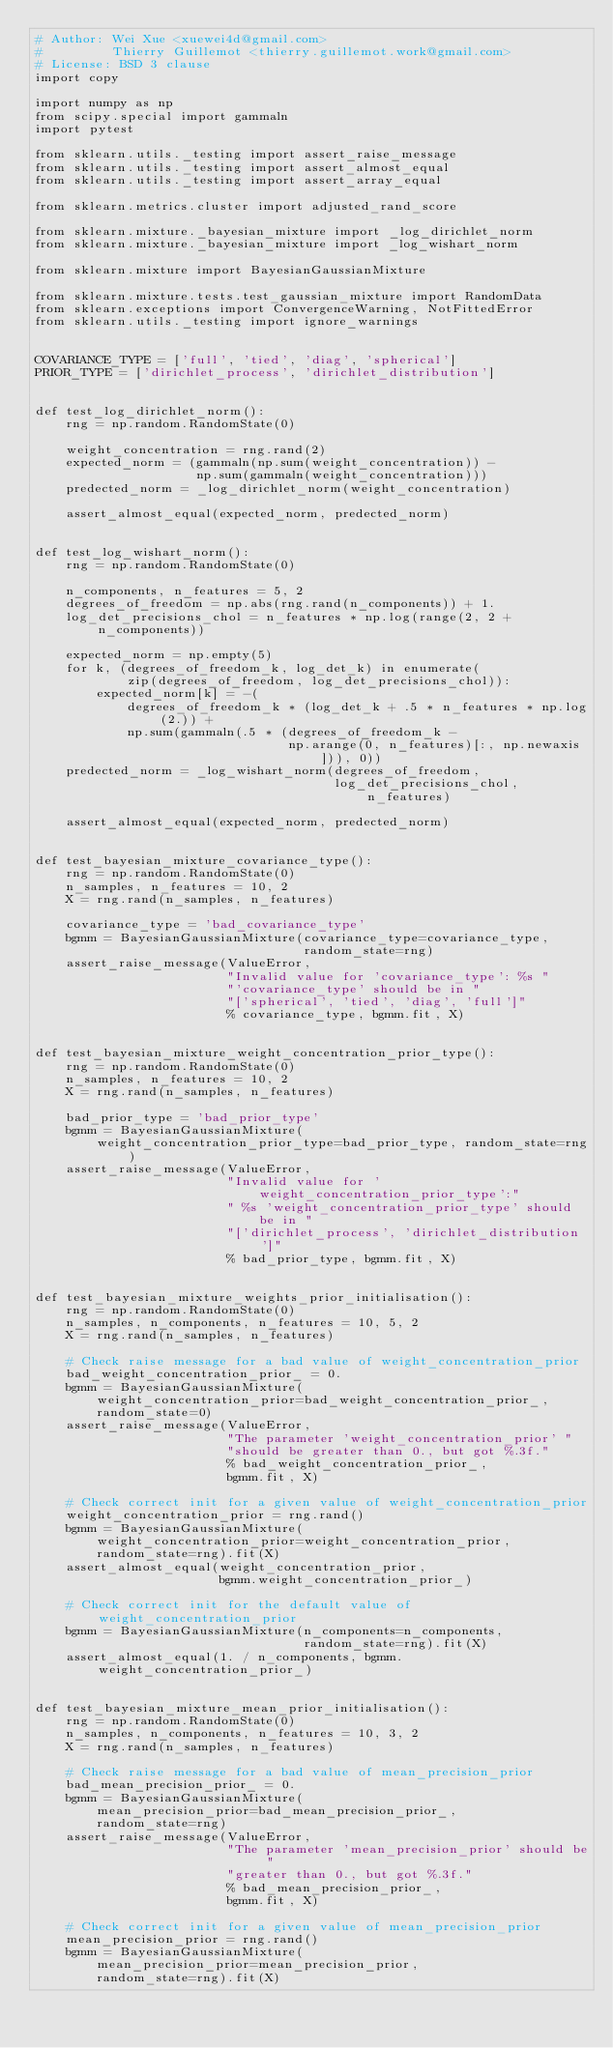<code> <loc_0><loc_0><loc_500><loc_500><_Python_># Author: Wei Xue <xuewei4d@gmail.com>
#         Thierry Guillemot <thierry.guillemot.work@gmail.com>
# License: BSD 3 clause
import copy

import numpy as np
from scipy.special import gammaln
import pytest

from sklearn.utils._testing import assert_raise_message
from sklearn.utils._testing import assert_almost_equal
from sklearn.utils._testing import assert_array_equal

from sklearn.metrics.cluster import adjusted_rand_score

from sklearn.mixture._bayesian_mixture import _log_dirichlet_norm
from sklearn.mixture._bayesian_mixture import _log_wishart_norm

from sklearn.mixture import BayesianGaussianMixture

from sklearn.mixture.tests.test_gaussian_mixture import RandomData
from sklearn.exceptions import ConvergenceWarning, NotFittedError
from sklearn.utils._testing import ignore_warnings


COVARIANCE_TYPE = ['full', 'tied', 'diag', 'spherical']
PRIOR_TYPE = ['dirichlet_process', 'dirichlet_distribution']


def test_log_dirichlet_norm():
    rng = np.random.RandomState(0)

    weight_concentration = rng.rand(2)
    expected_norm = (gammaln(np.sum(weight_concentration)) -
                     np.sum(gammaln(weight_concentration)))
    predected_norm = _log_dirichlet_norm(weight_concentration)

    assert_almost_equal(expected_norm, predected_norm)


def test_log_wishart_norm():
    rng = np.random.RandomState(0)

    n_components, n_features = 5, 2
    degrees_of_freedom = np.abs(rng.rand(n_components)) + 1.
    log_det_precisions_chol = n_features * np.log(range(2, 2 + n_components))

    expected_norm = np.empty(5)
    for k, (degrees_of_freedom_k, log_det_k) in enumerate(
            zip(degrees_of_freedom, log_det_precisions_chol)):
        expected_norm[k] = -(
            degrees_of_freedom_k * (log_det_k + .5 * n_features * np.log(2.)) +
            np.sum(gammaln(.5 * (degrees_of_freedom_k -
                                 np.arange(0, n_features)[:, np.newaxis])), 0))
    predected_norm = _log_wishart_norm(degrees_of_freedom,
                                       log_det_precisions_chol, n_features)

    assert_almost_equal(expected_norm, predected_norm)


def test_bayesian_mixture_covariance_type():
    rng = np.random.RandomState(0)
    n_samples, n_features = 10, 2
    X = rng.rand(n_samples, n_features)

    covariance_type = 'bad_covariance_type'
    bgmm = BayesianGaussianMixture(covariance_type=covariance_type,
                                   random_state=rng)
    assert_raise_message(ValueError,
                         "Invalid value for 'covariance_type': %s "
                         "'covariance_type' should be in "
                         "['spherical', 'tied', 'diag', 'full']"
                         % covariance_type, bgmm.fit, X)


def test_bayesian_mixture_weight_concentration_prior_type():
    rng = np.random.RandomState(0)
    n_samples, n_features = 10, 2
    X = rng.rand(n_samples, n_features)

    bad_prior_type = 'bad_prior_type'
    bgmm = BayesianGaussianMixture(
        weight_concentration_prior_type=bad_prior_type, random_state=rng)
    assert_raise_message(ValueError,
                         "Invalid value for 'weight_concentration_prior_type':"
                         " %s 'weight_concentration_prior_type' should be in "
                         "['dirichlet_process', 'dirichlet_distribution']"
                         % bad_prior_type, bgmm.fit, X)


def test_bayesian_mixture_weights_prior_initialisation():
    rng = np.random.RandomState(0)
    n_samples, n_components, n_features = 10, 5, 2
    X = rng.rand(n_samples, n_features)

    # Check raise message for a bad value of weight_concentration_prior
    bad_weight_concentration_prior_ = 0.
    bgmm = BayesianGaussianMixture(
        weight_concentration_prior=bad_weight_concentration_prior_,
        random_state=0)
    assert_raise_message(ValueError,
                         "The parameter 'weight_concentration_prior' "
                         "should be greater than 0., but got %.3f."
                         % bad_weight_concentration_prior_,
                         bgmm.fit, X)

    # Check correct init for a given value of weight_concentration_prior
    weight_concentration_prior = rng.rand()
    bgmm = BayesianGaussianMixture(
        weight_concentration_prior=weight_concentration_prior,
        random_state=rng).fit(X)
    assert_almost_equal(weight_concentration_prior,
                        bgmm.weight_concentration_prior_)

    # Check correct init for the default value of weight_concentration_prior
    bgmm = BayesianGaussianMixture(n_components=n_components,
                                   random_state=rng).fit(X)
    assert_almost_equal(1. / n_components, bgmm.weight_concentration_prior_)


def test_bayesian_mixture_mean_prior_initialisation():
    rng = np.random.RandomState(0)
    n_samples, n_components, n_features = 10, 3, 2
    X = rng.rand(n_samples, n_features)

    # Check raise message for a bad value of mean_precision_prior
    bad_mean_precision_prior_ = 0.
    bgmm = BayesianGaussianMixture(
        mean_precision_prior=bad_mean_precision_prior_,
        random_state=rng)
    assert_raise_message(ValueError,
                         "The parameter 'mean_precision_prior' should be "
                         "greater than 0., but got %.3f."
                         % bad_mean_precision_prior_,
                         bgmm.fit, X)

    # Check correct init for a given value of mean_precision_prior
    mean_precision_prior = rng.rand()
    bgmm = BayesianGaussianMixture(
        mean_precision_prior=mean_precision_prior,
        random_state=rng).fit(X)</code> 